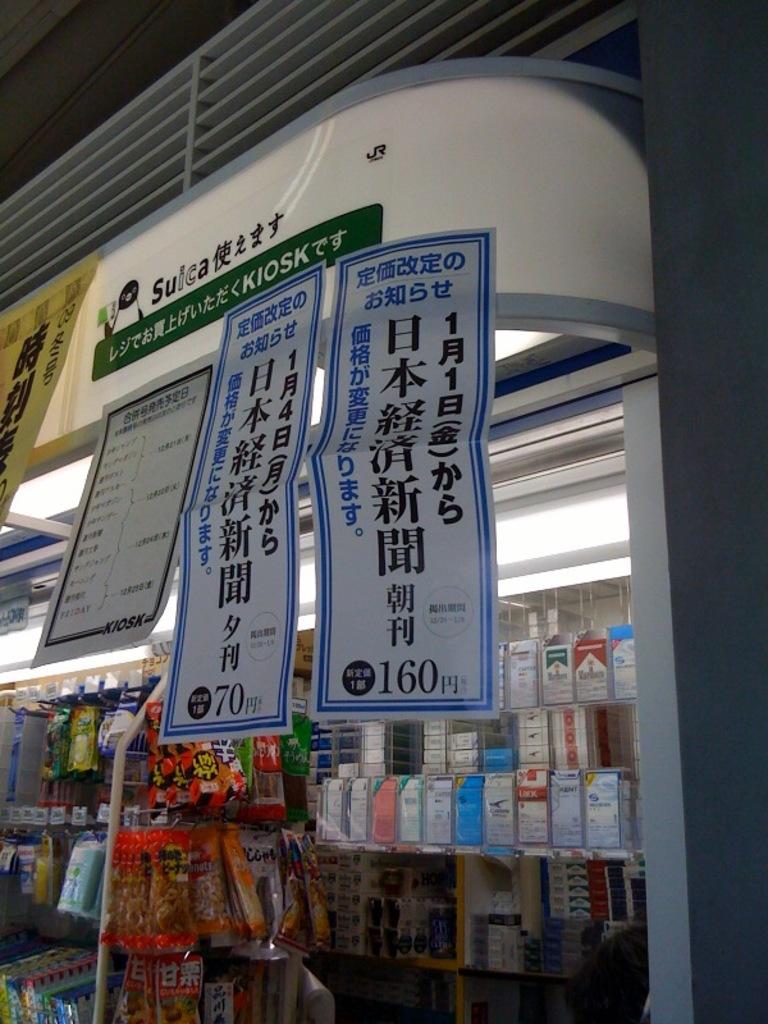What number is at the bottom of the sign on the right?
Your response must be concise. 160. 